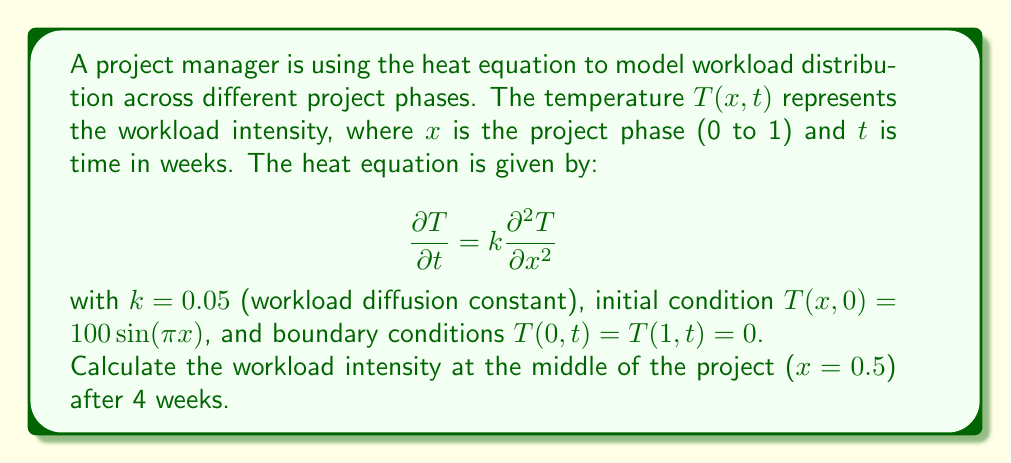Provide a solution to this math problem. To solve this problem, we'll use the separation of variables method for the heat equation:

1) The general solution for this problem is:

   $$T(x,t) = \sum_{n=1}^{\infty} B_n \sin(n\pi x)e^{-kn^2\pi^2t}$$

2) Given the initial condition $T(x,0) = 100\sin(\pi x)$, we can see that only the first term of the series ($n=1$) is non-zero, with $B_1 = 100$.

3) Therefore, our solution simplifies to:

   $$T(x,t) = 100 \sin(\pi x)e^{-k\pi^2t}$$

4) Now, we need to calculate $T(0.5, 4)$. Let's substitute the values:

   $$T(0.5, 4) = 100 \sin(\pi \cdot 0.5)e^{-0.05\pi^2 \cdot 4}$$

5) Simplify:
   - $\sin(\pi \cdot 0.5) = \sin(\frac{\pi}{2}) = 1$
   - $e^{-0.05\pi^2 \cdot 4} = e^{-0.2\pi^2} \approx 0.1353$

6) Calculate the final result:

   $$T(0.5, 4) = 100 \cdot 1 \cdot 0.1353 \approx 13.53$$

Therefore, the workload intensity at the middle of the project after 4 weeks is approximately 13.53.
Answer: 13.53 